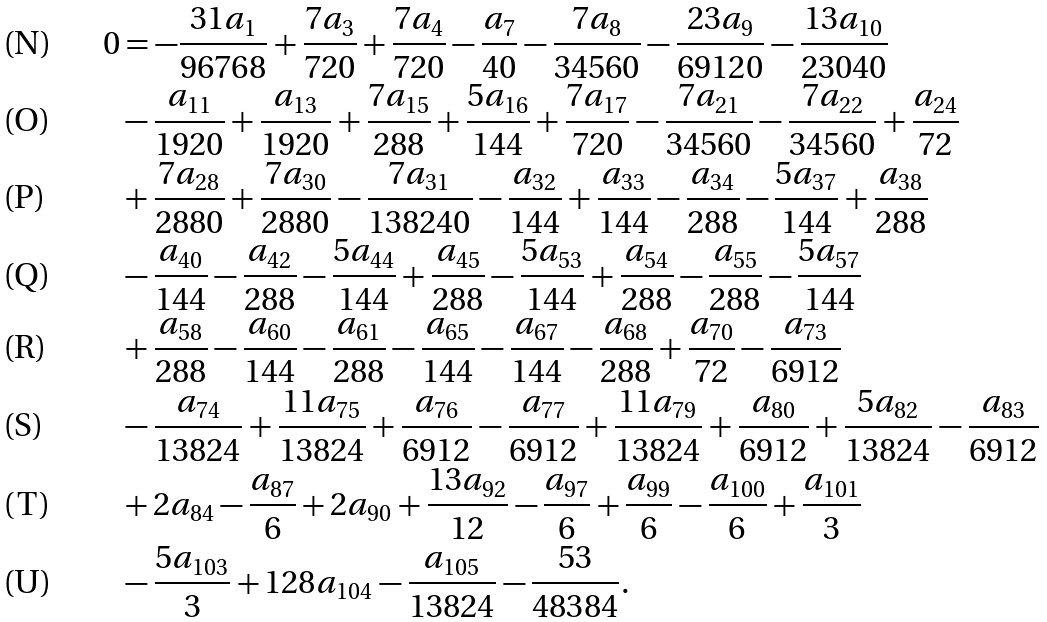<formula> <loc_0><loc_0><loc_500><loc_500>0 & = - \frac { 3 1 a _ { 1 } } { 9 6 7 6 8 } + \frac { 7 a _ { 3 } } { 7 2 0 } + \frac { 7 a _ { 4 } } { 7 2 0 } - \frac { a _ { 7 } } { 4 0 } - \frac { 7 a _ { 8 } } { 3 4 5 6 0 } - \frac { 2 3 a _ { 9 } } { 6 9 1 2 0 } - \frac { 1 3 a _ { 1 0 } } { 2 3 0 4 0 } \\ & - \frac { a _ { 1 1 } } { 1 9 2 0 } + \frac { a _ { 1 3 } } { 1 9 2 0 } + \frac { 7 a _ { 1 5 } } { 2 8 8 } + \frac { 5 a _ { 1 6 } } { 1 4 4 } + \frac { 7 a _ { 1 7 } } { 7 2 0 } - \frac { 7 a _ { 2 1 } } { 3 4 5 6 0 } - \frac { 7 a _ { 2 2 } } { 3 4 5 6 0 } + \frac { a _ { 2 4 } } { 7 2 } \\ & + \frac { 7 a _ { 2 8 } } { 2 8 8 0 } + \frac { 7 a _ { 3 0 } } { 2 8 8 0 } - \frac { 7 a _ { 3 1 } } { 1 3 8 2 4 0 } - \frac { a _ { 3 2 } } { 1 4 4 } + \frac { a _ { 3 3 } } { 1 4 4 } - \frac { a _ { 3 4 } } { 2 8 8 } - \frac { 5 a _ { 3 7 } } { 1 4 4 } + \frac { a _ { 3 8 } } { 2 8 8 } \\ & - \frac { a _ { 4 0 } } { 1 4 4 } - \frac { a _ { 4 2 } } { 2 8 8 } - \frac { 5 a _ { 4 4 } } { 1 4 4 } + \frac { a _ { 4 5 } } { 2 8 8 } - \frac { 5 a _ { 5 3 } } { 1 4 4 } + \frac { a _ { 5 4 } } { 2 8 8 } - \frac { a _ { 5 5 } } { 2 8 8 } - \frac { 5 a _ { 5 7 } } { 1 4 4 } \\ & + \frac { a _ { 5 8 } } { 2 8 8 } - \frac { a _ { 6 0 } } { 1 4 4 } - \frac { a _ { 6 1 } } { 2 8 8 } - \frac { a _ { 6 5 } } { 1 4 4 } - \frac { a _ { 6 7 } } { 1 4 4 } - \frac { a _ { 6 8 } } { 2 8 8 } + \frac { a _ { 7 0 } } { 7 2 } - \frac { a _ { 7 3 } } { 6 9 1 2 } \\ & - \frac { a _ { 7 4 } } { 1 3 8 2 4 } + \frac { 1 1 a _ { 7 5 } } { 1 3 8 2 4 } + \frac { a _ { 7 6 } } { 6 9 1 2 } - \frac { a _ { 7 7 } } { 6 9 1 2 } + \frac { 1 1 a _ { 7 9 } } { 1 3 8 2 4 } + \frac { a _ { 8 0 } } { 6 9 1 2 } + \frac { 5 a _ { 8 2 } } { 1 3 8 2 4 } - \frac { a _ { 8 3 } } { 6 9 1 2 } \\ & + 2 a _ { 8 4 } - \frac { a _ { 8 7 } } { 6 } + 2 a _ { 9 0 } + \frac { 1 3 a _ { 9 2 } } { 1 2 } - \frac { a _ { 9 7 } } { 6 } + \frac { a _ { 9 9 } } { 6 } - \frac { a _ { 1 0 0 } } { 6 } + \frac { a _ { 1 0 1 } } { 3 } \\ & - \frac { 5 a _ { 1 0 3 } } { 3 } + 1 2 8 a _ { 1 0 4 } - \frac { a _ { 1 0 5 } } { 1 3 8 2 4 } - \frac { 5 3 } { 4 8 3 8 4 } .</formula> 